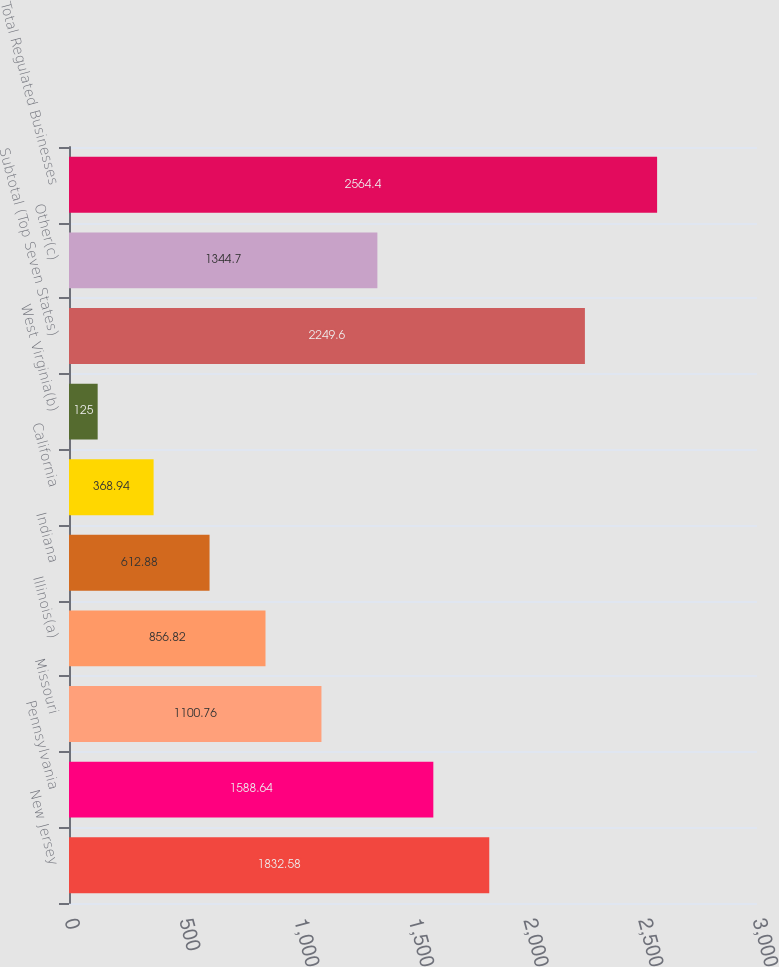Convert chart. <chart><loc_0><loc_0><loc_500><loc_500><bar_chart><fcel>New Jersey<fcel>Pennsylvania<fcel>Missouri<fcel>Illinois(a)<fcel>Indiana<fcel>California<fcel>West Virginia(b)<fcel>Subtotal (Top Seven States)<fcel>Other(c)<fcel>Total Regulated Businesses<nl><fcel>1832.58<fcel>1588.64<fcel>1100.76<fcel>856.82<fcel>612.88<fcel>368.94<fcel>125<fcel>2249.6<fcel>1344.7<fcel>2564.4<nl></chart> 